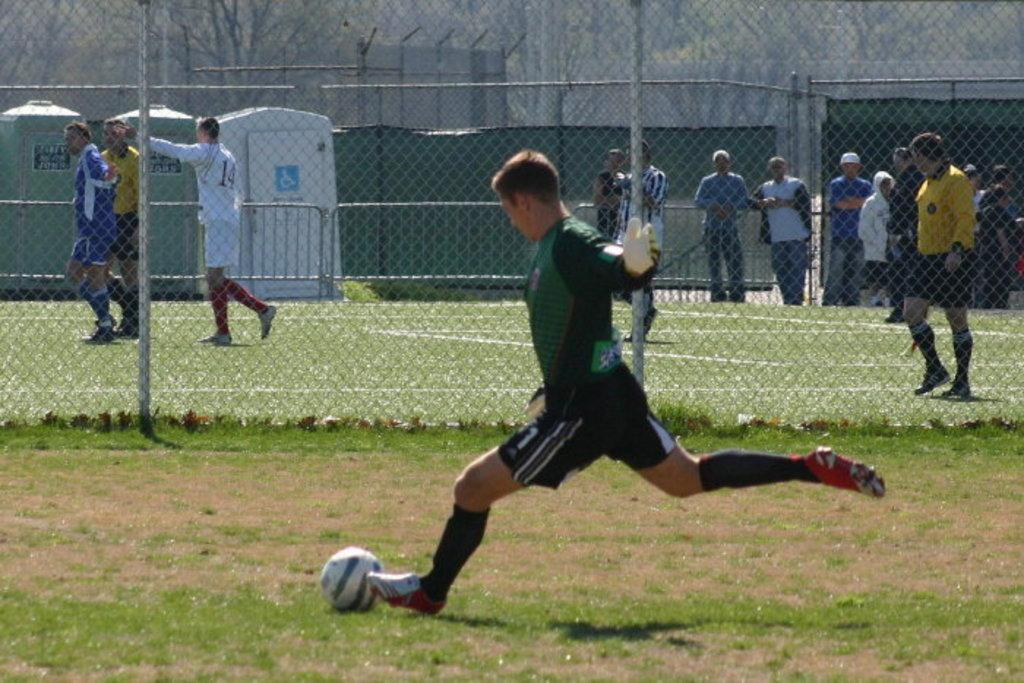What is the main subject of the image? There is a person in the image. What object is visible near the person? There is a ball in the image. Can you describe the background of the image? There are people, a fence, trees, and restroom cabins visible in the background. What type of wire can be seen connecting the trees in the image? There is no wire connecting the trees in the image; only a fence is visible in the background. How many bears are visible in the image? There are no bears present in the image. 